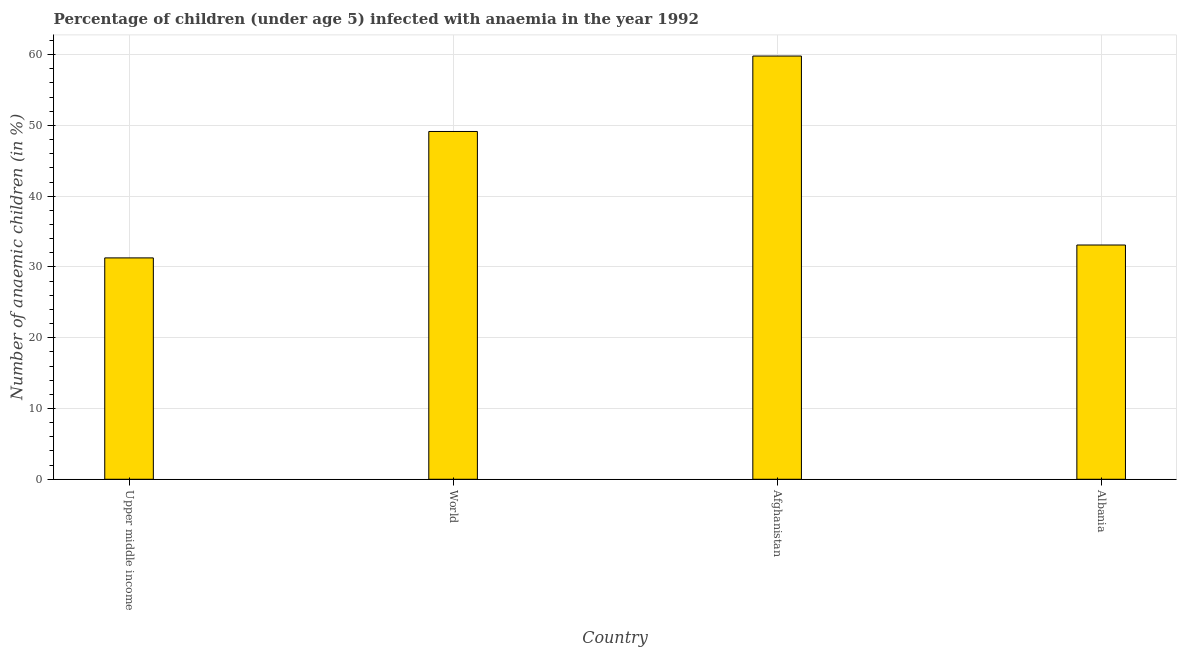What is the title of the graph?
Provide a succinct answer. Percentage of children (under age 5) infected with anaemia in the year 1992. What is the label or title of the Y-axis?
Keep it short and to the point. Number of anaemic children (in %). What is the number of anaemic children in Albania?
Provide a short and direct response. 33.1. Across all countries, what is the maximum number of anaemic children?
Make the answer very short. 59.8. Across all countries, what is the minimum number of anaemic children?
Make the answer very short. 31.28. In which country was the number of anaemic children maximum?
Your response must be concise. Afghanistan. In which country was the number of anaemic children minimum?
Your answer should be compact. Upper middle income. What is the sum of the number of anaemic children?
Your answer should be very brief. 173.32. What is the difference between the number of anaemic children in Afghanistan and Upper middle income?
Offer a terse response. 28.52. What is the average number of anaemic children per country?
Your response must be concise. 43.33. What is the median number of anaemic children?
Provide a succinct answer. 41.12. What is the ratio of the number of anaemic children in Afghanistan to that in Albania?
Give a very brief answer. 1.81. What is the difference between the highest and the second highest number of anaemic children?
Make the answer very short. 10.66. What is the difference between the highest and the lowest number of anaemic children?
Offer a very short reply. 28.52. How many countries are there in the graph?
Provide a succinct answer. 4. Are the values on the major ticks of Y-axis written in scientific E-notation?
Ensure brevity in your answer.  No. What is the Number of anaemic children (in %) of Upper middle income?
Offer a very short reply. 31.28. What is the Number of anaemic children (in %) of World?
Offer a very short reply. 49.14. What is the Number of anaemic children (in %) in Afghanistan?
Offer a very short reply. 59.8. What is the Number of anaemic children (in %) in Albania?
Keep it short and to the point. 33.1. What is the difference between the Number of anaemic children (in %) in Upper middle income and World?
Provide a short and direct response. -17.86. What is the difference between the Number of anaemic children (in %) in Upper middle income and Afghanistan?
Offer a very short reply. -28.52. What is the difference between the Number of anaemic children (in %) in Upper middle income and Albania?
Make the answer very short. -1.82. What is the difference between the Number of anaemic children (in %) in World and Afghanistan?
Provide a succinct answer. -10.66. What is the difference between the Number of anaemic children (in %) in World and Albania?
Your answer should be compact. 16.04. What is the difference between the Number of anaemic children (in %) in Afghanistan and Albania?
Provide a short and direct response. 26.7. What is the ratio of the Number of anaemic children (in %) in Upper middle income to that in World?
Your response must be concise. 0.64. What is the ratio of the Number of anaemic children (in %) in Upper middle income to that in Afghanistan?
Make the answer very short. 0.52. What is the ratio of the Number of anaemic children (in %) in Upper middle income to that in Albania?
Make the answer very short. 0.94. What is the ratio of the Number of anaemic children (in %) in World to that in Afghanistan?
Your answer should be very brief. 0.82. What is the ratio of the Number of anaemic children (in %) in World to that in Albania?
Offer a very short reply. 1.49. What is the ratio of the Number of anaemic children (in %) in Afghanistan to that in Albania?
Provide a short and direct response. 1.81. 